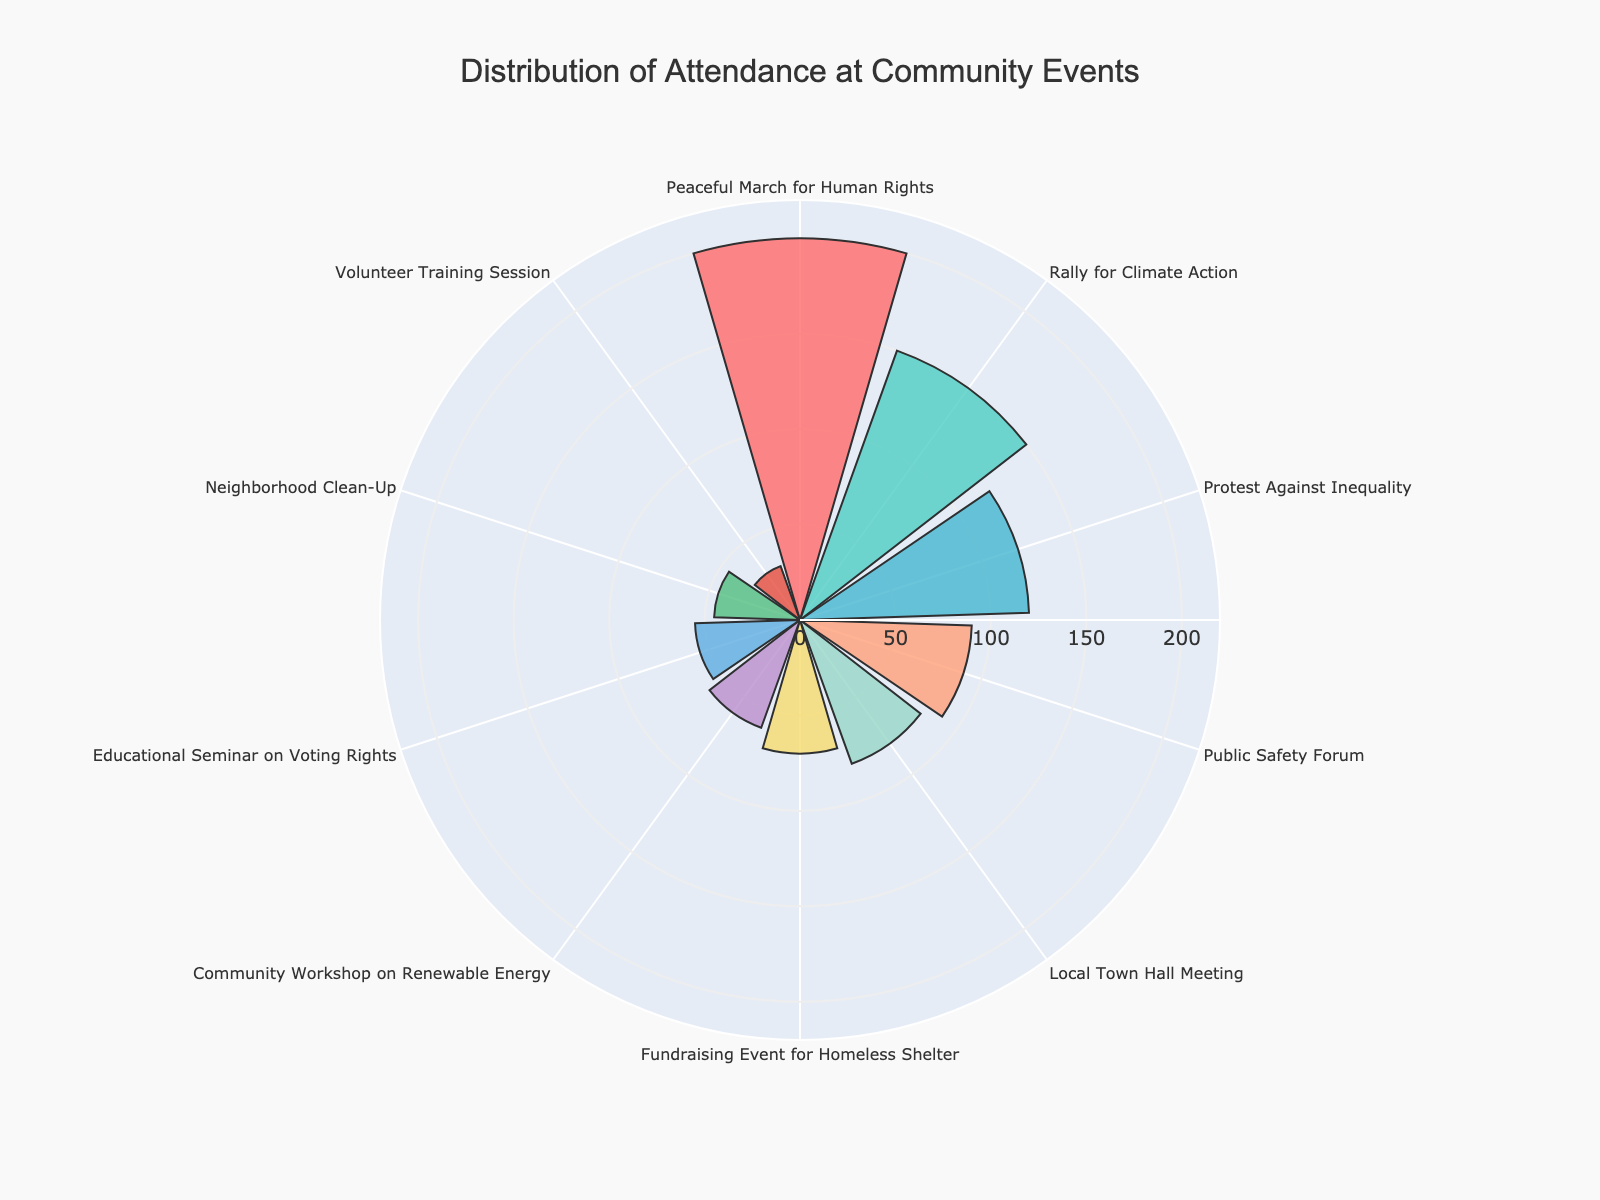What is the title of the figure? The title is usually placed at the top of the figure and provides a succinct summary of its content. In this case, the title indicates the nature of the data being visualized.
Answer: Distribution of Attendance at Community Events Which event type had the highest attendance? To determine this, examine the segment with the largest radial length in the polar area chart. This segment reflects the highest attendance figure.
Answer: Peaceful March for Human Rights How many event types are represented in the chart? Count the number of different segments or labels around the polar chart's perimeter to find the total number of event types.
Answer: 10 What is the difference in attendance between the Local Town Hall Meeting and the Neighborhood Clean-Up? Locate the radial lengths representing the Local Town Hall Meeting (80) and the Neighborhood Clean-Up (45). Then, calculate the difference between these two values: 80 - 45.
Answer: 35 Which event type had the second lowest attendance, and what was the value? Identify the segment with the second smallest radial length. The smallest segment represents the Volunteer Training Session, so the next smallest is the Neighborhood Clean-Up.
Answer: Neighborhood Clean-Up, 45 How does the attendance at the Rally for Climate Action compare to that of the Protest Against Inequality? Compare the radial lengths of the segments for these two event types. The Rally for Climate Action has an attendance of 150, while the Protest Against Inequality has 120. Therefore, the Rally for Climate Action had higher attendance.
Answer: Rally for Climate Action had higher attendance What is the average attendance across all event types? Add the attendance figures for all event types (150 + 60 + 80 + 120 + 45 + 70 + 200 + 55 + 30 + 90), then divide by the number of events (10). Total attendance is 900, so the average is 900/10.
Answer: 90 What proportion of total attendees were present at the Peaceful March for Human Rights? The attendance at the Peaceful March for Human Rights is 200. The total attendance is 900. Calculate the proportion by dividing 200 by 900 and then converting to a percentage: (200 / 900) * 100.
Answer: 22.22% Which three event types had attendance figures closest to the average attendance? The average attendance is 90. Identify the event types with attendance figures near this average: Local Town Hall Meeting (80), Fundraising Event for Homeless Shelter (70), and Public Safety Forum (90). Evaluate these distances: 80-90 = 10, 90-90 = 0, 70-90 = 20.
Answer: Public Safety Forum, Local Town Hall Meeting, Fundraising Event for Homeless Shelter Is there a type of event that consistently attracted more attendees than others? Analyze the radial lengths of the segments to see if any specific type of event tends to have longer segments. The "Peaceful March for Human Rights" stands out as it has the largest segment.
Answer: Peaceful March for Human Rights 